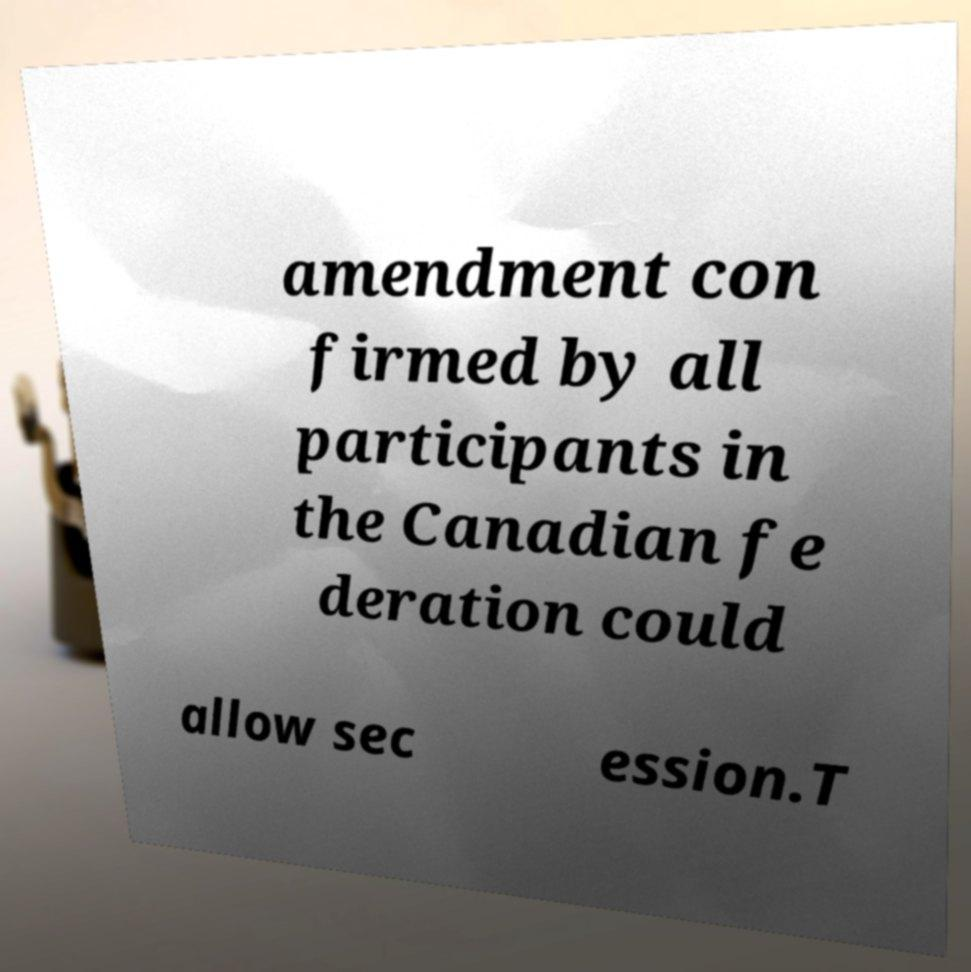Please identify and transcribe the text found in this image. amendment con firmed by all participants in the Canadian fe deration could allow sec ession.T 